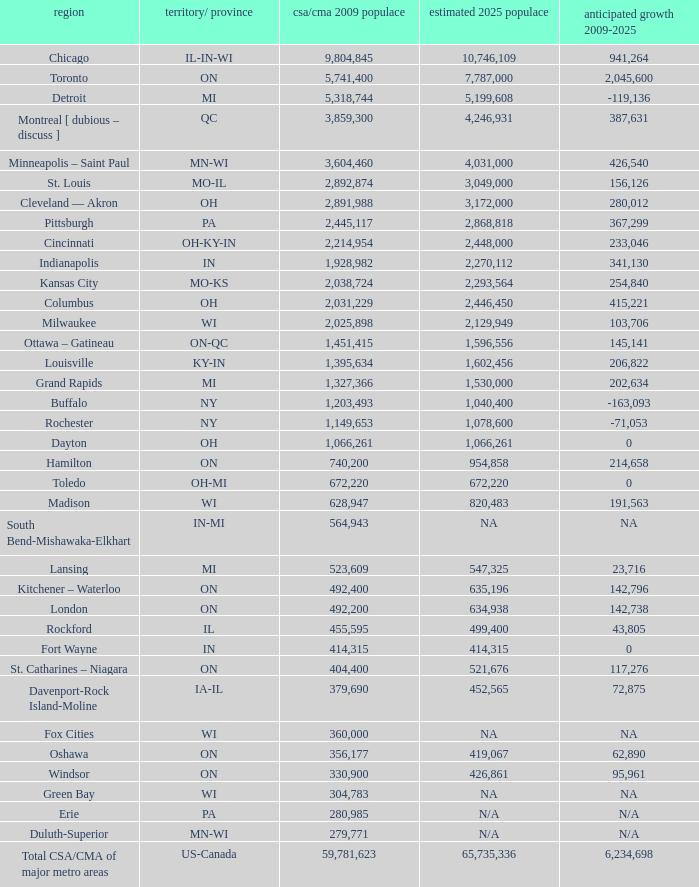What's the projected population of IN-MI? NA. 